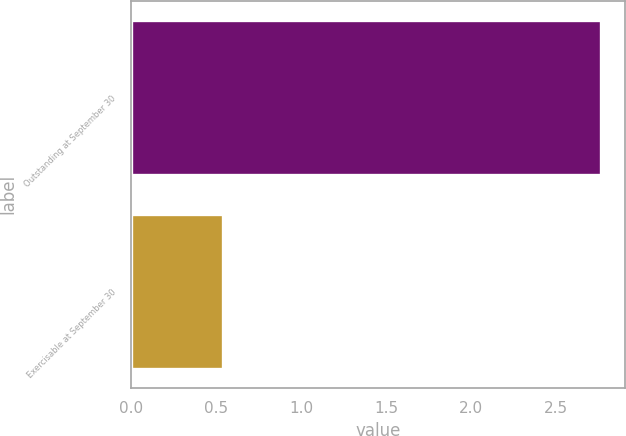Convert chart. <chart><loc_0><loc_0><loc_500><loc_500><bar_chart><fcel>Outstanding at September 30<fcel>Exercisable at September 30<nl><fcel>2.77<fcel>0.54<nl></chart> 